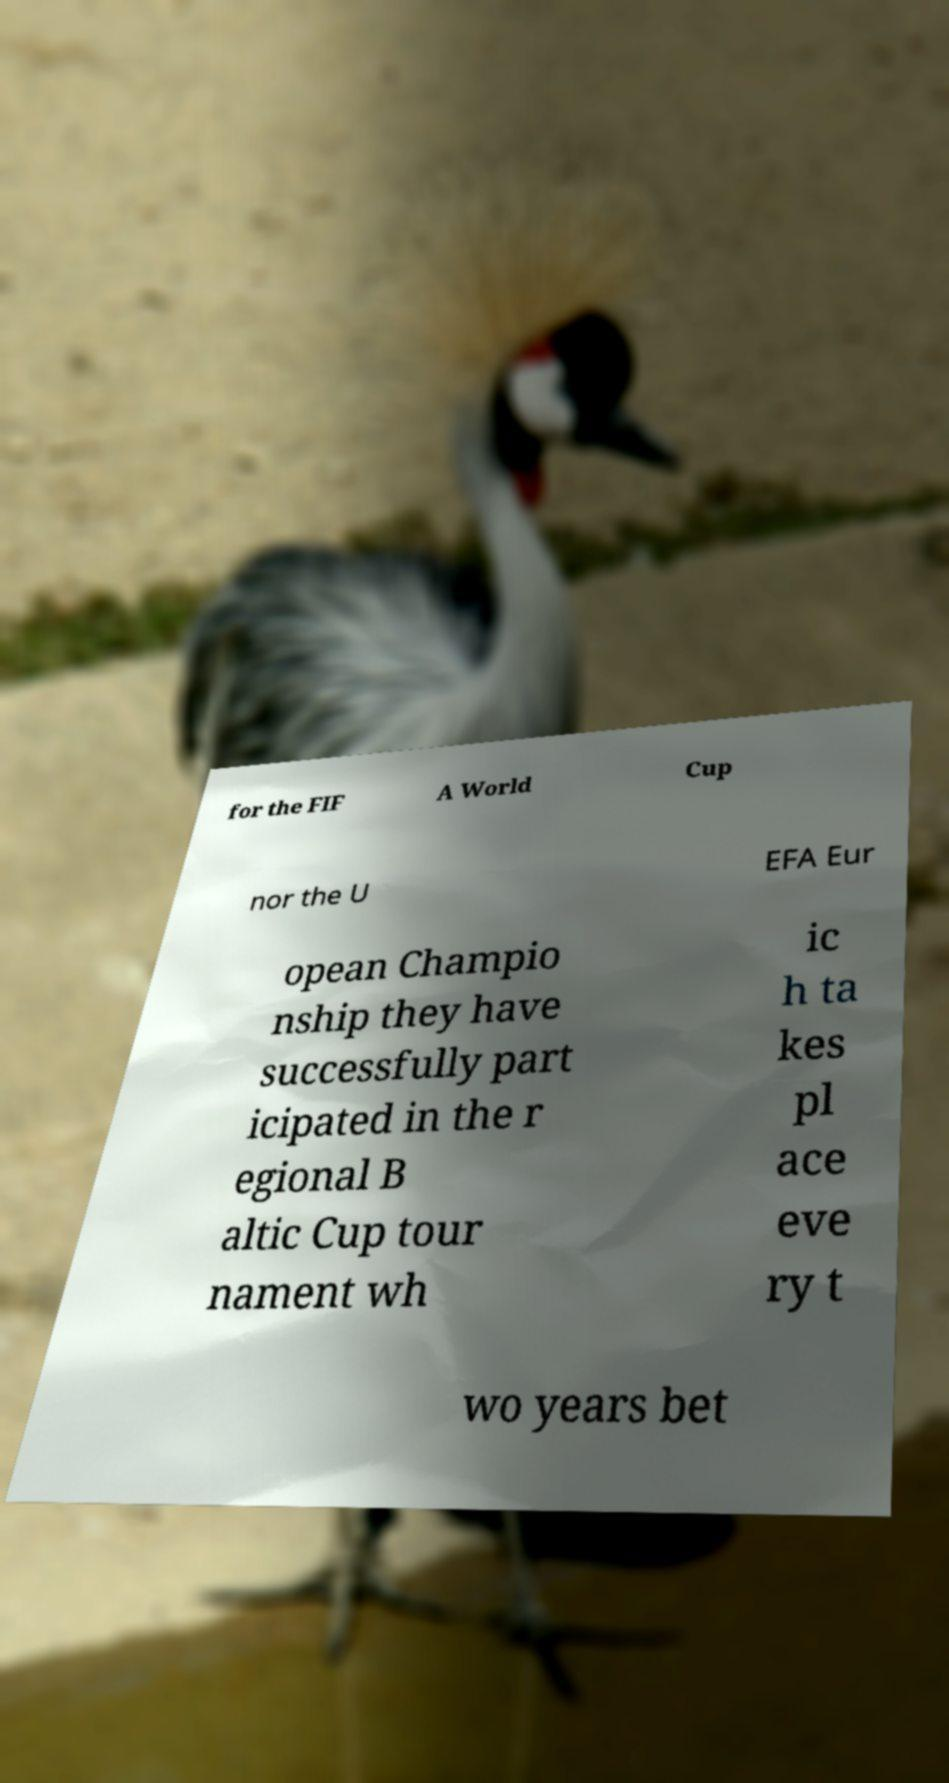Could you extract and type out the text from this image? for the FIF A World Cup nor the U EFA Eur opean Champio nship they have successfully part icipated in the r egional B altic Cup tour nament wh ic h ta kes pl ace eve ry t wo years bet 